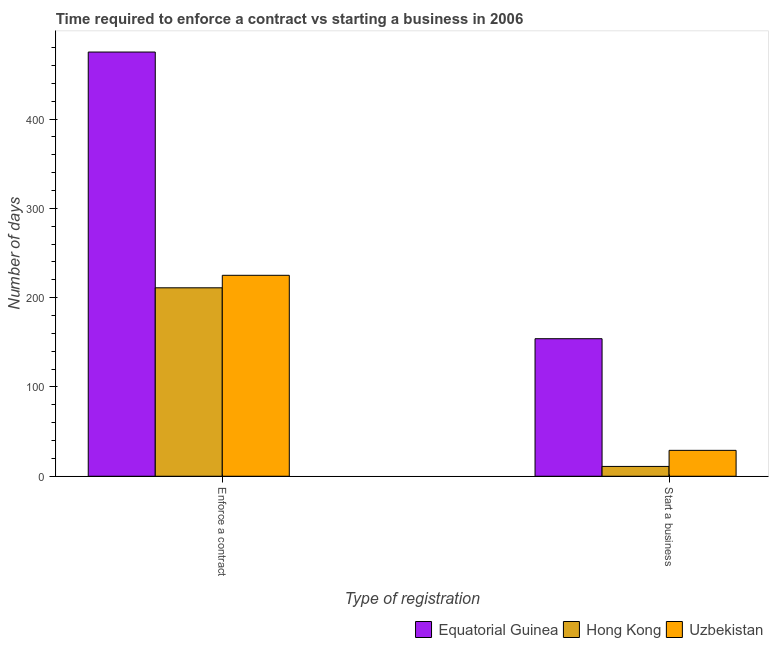How many groups of bars are there?
Keep it short and to the point. 2. How many bars are there on the 1st tick from the left?
Ensure brevity in your answer.  3. What is the label of the 2nd group of bars from the left?
Your response must be concise. Start a business. What is the number of days to enforece a contract in Uzbekistan?
Offer a terse response. 225. Across all countries, what is the maximum number of days to enforece a contract?
Offer a very short reply. 475. Across all countries, what is the minimum number of days to start a business?
Offer a terse response. 11. In which country was the number of days to enforece a contract maximum?
Provide a short and direct response. Equatorial Guinea. In which country was the number of days to start a business minimum?
Ensure brevity in your answer.  Hong Kong. What is the total number of days to start a business in the graph?
Give a very brief answer. 194. What is the difference between the number of days to start a business in Hong Kong and that in Equatorial Guinea?
Offer a terse response. -143. What is the difference between the number of days to start a business in Hong Kong and the number of days to enforece a contract in Equatorial Guinea?
Make the answer very short. -464. What is the average number of days to enforece a contract per country?
Your response must be concise. 303.67. What is the difference between the number of days to start a business and number of days to enforece a contract in Hong Kong?
Your answer should be compact. -200. What is the ratio of the number of days to start a business in Equatorial Guinea to that in Uzbekistan?
Your answer should be very brief. 5.31. Is the number of days to enforece a contract in Hong Kong less than that in Equatorial Guinea?
Your response must be concise. Yes. What does the 3rd bar from the left in Start a business represents?
Keep it short and to the point. Uzbekistan. What does the 3rd bar from the right in Start a business represents?
Provide a succinct answer. Equatorial Guinea. How many bars are there?
Your answer should be compact. 6. Are all the bars in the graph horizontal?
Ensure brevity in your answer.  No. How many countries are there in the graph?
Your answer should be compact. 3. Does the graph contain any zero values?
Provide a succinct answer. No. Does the graph contain grids?
Ensure brevity in your answer.  No. How are the legend labels stacked?
Your response must be concise. Horizontal. What is the title of the graph?
Keep it short and to the point. Time required to enforce a contract vs starting a business in 2006. What is the label or title of the X-axis?
Your response must be concise. Type of registration. What is the label or title of the Y-axis?
Keep it short and to the point. Number of days. What is the Number of days in Equatorial Guinea in Enforce a contract?
Provide a succinct answer. 475. What is the Number of days in Hong Kong in Enforce a contract?
Ensure brevity in your answer.  211. What is the Number of days in Uzbekistan in Enforce a contract?
Give a very brief answer. 225. What is the Number of days of Equatorial Guinea in Start a business?
Give a very brief answer. 154. What is the Number of days in Hong Kong in Start a business?
Offer a very short reply. 11. What is the Number of days of Uzbekistan in Start a business?
Your answer should be compact. 29. Across all Type of registration, what is the maximum Number of days of Equatorial Guinea?
Keep it short and to the point. 475. Across all Type of registration, what is the maximum Number of days of Hong Kong?
Offer a very short reply. 211. Across all Type of registration, what is the maximum Number of days of Uzbekistan?
Provide a short and direct response. 225. Across all Type of registration, what is the minimum Number of days in Equatorial Guinea?
Provide a succinct answer. 154. What is the total Number of days of Equatorial Guinea in the graph?
Offer a very short reply. 629. What is the total Number of days of Hong Kong in the graph?
Your response must be concise. 222. What is the total Number of days of Uzbekistan in the graph?
Offer a very short reply. 254. What is the difference between the Number of days in Equatorial Guinea in Enforce a contract and that in Start a business?
Provide a succinct answer. 321. What is the difference between the Number of days of Uzbekistan in Enforce a contract and that in Start a business?
Offer a terse response. 196. What is the difference between the Number of days of Equatorial Guinea in Enforce a contract and the Number of days of Hong Kong in Start a business?
Ensure brevity in your answer.  464. What is the difference between the Number of days in Equatorial Guinea in Enforce a contract and the Number of days in Uzbekistan in Start a business?
Give a very brief answer. 446. What is the difference between the Number of days in Hong Kong in Enforce a contract and the Number of days in Uzbekistan in Start a business?
Offer a terse response. 182. What is the average Number of days in Equatorial Guinea per Type of registration?
Offer a terse response. 314.5. What is the average Number of days in Hong Kong per Type of registration?
Give a very brief answer. 111. What is the average Number of days in Uzbekistan per Type of registration?
Provide a succinct answer. 127. What is the difference between the Number of days of Equatorial Guinea and Number of days of Hong Kong in Enforce a contract?
Ensure brevity in your answer.  264. What is the difference between the Number of days in Equatorial Guinea and Number of days in Uzbekistan in Enforce a contract?
Provide a short and direct response. 250. What is the difference between the Number of days of Equatorial Guinea and Number of days of Hong Kong in Start a business?
Your answer should be compact. 143. What is the difference between the Number of days in Equatorial Guinea and Number of days in Uzbekistan in Start a business?
Give a very brief answer. 125. What is the ratio of the Number of days of Equatorial Guinea in Enforce a contract to that in Start a business?
Keep it short and to the point. 3.08. What is the ratio of the Number of days in Hong Kong in Enforce a contract to that in Start a business?
Ensure brevity in your answer.  19.18. What is the ratio of the Number of days in Uzbekistan in Enforce a contract to that in Start a business?
Your answer should be compact. 7.76. What is the difference between the highest and the second highest Number of days of Equatorial Guinea?
Your answer should be very brief. 321. What is the difference between the highest and the second highest Number of days of Hong Kong?
Provide a short and direct response. 200. What is the difference between the highest and the second highest Number of days in Uzbekistan?
Ensure brevity in your answer.  196. What is the difference between the highest and the lowest Number of days of Equatorial Guinea?
Your answer should be very brief. 321. What is the difference between the highest and the lowest Number of days in Uzbekistan?
Make the answer very short. 196. 